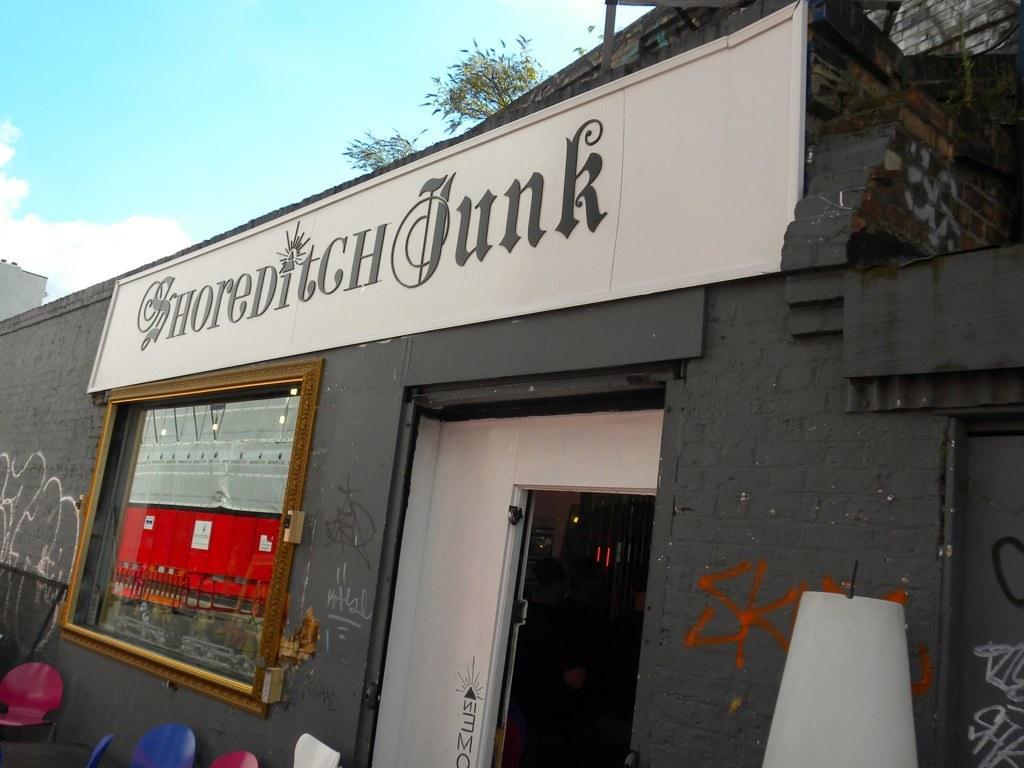Can you describe this image briefly? This image consists of a restaurant along with a door and a window. At the top, there is a sky. 